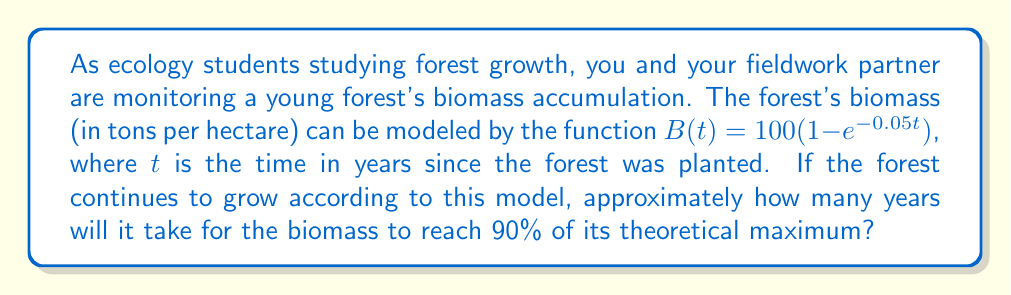Provide a solution to this math problem. Let's approach this step-by-step:

1) First, we need to understand what the equation represents:
   $B(t) = 100(1 - e^{-0.05t})$
   
   Here, 100 represents the theoretical maximum biomass in tons per hectare.

2) We want to find when the biomass reaches 90% of this maximum, so we're looking for $t$ when:
   $B(t) = 0.90 * 100 = 90$

3) Let's set up the equation:
   $90 = 100(1 - e^{-0.05t})$

4) Divide both sides by 100:
   $0.90 = 1 - e^{-0.05t}$

5) Subtract both sides from 1:
   $0.10 = e^{-0.05t}$

6) Take the natural log of both sides:
   $\ln(0.10) = -0.05t$

7) Solve for $t$:
   $t = \frac{\ln(0.10)}{-0.05}$

8) Calculate:
   $t = \frac{-2.30259}{-0.05} \approx 46.05$ years

9) Since we're asked for an approximate answer in years, we'll round to the nearest whole number.
Answer: Approximately 46 years 